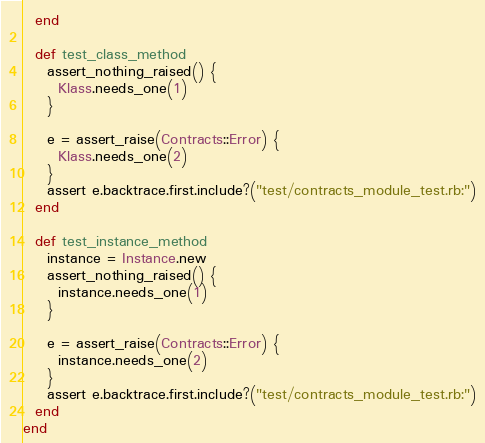<code> <loc_0><loc_0><loc_500><loc_500><_Ruby_>  end

  def test_class_method
    assert_nothing_raised() {
      Klass.needs_one(1)
    }

    e = assert_raise(Contracts::Error) {
      Klass.needs_one(2)
    }
    assert e.backtrace.first.include?("test/contracts_module_test.rb:")
  end

  def test_instance_method
    instance = Instance.new
    assert_nothing_raised() {
      instance.needs_one(1)
    }

    e = assert_raise(Contracts::Error) {
      instance.needs_one(2)
    }
    assert e.backtrace.first.include?("test/contracts_module_test.rb:")
  end
end
</code> 